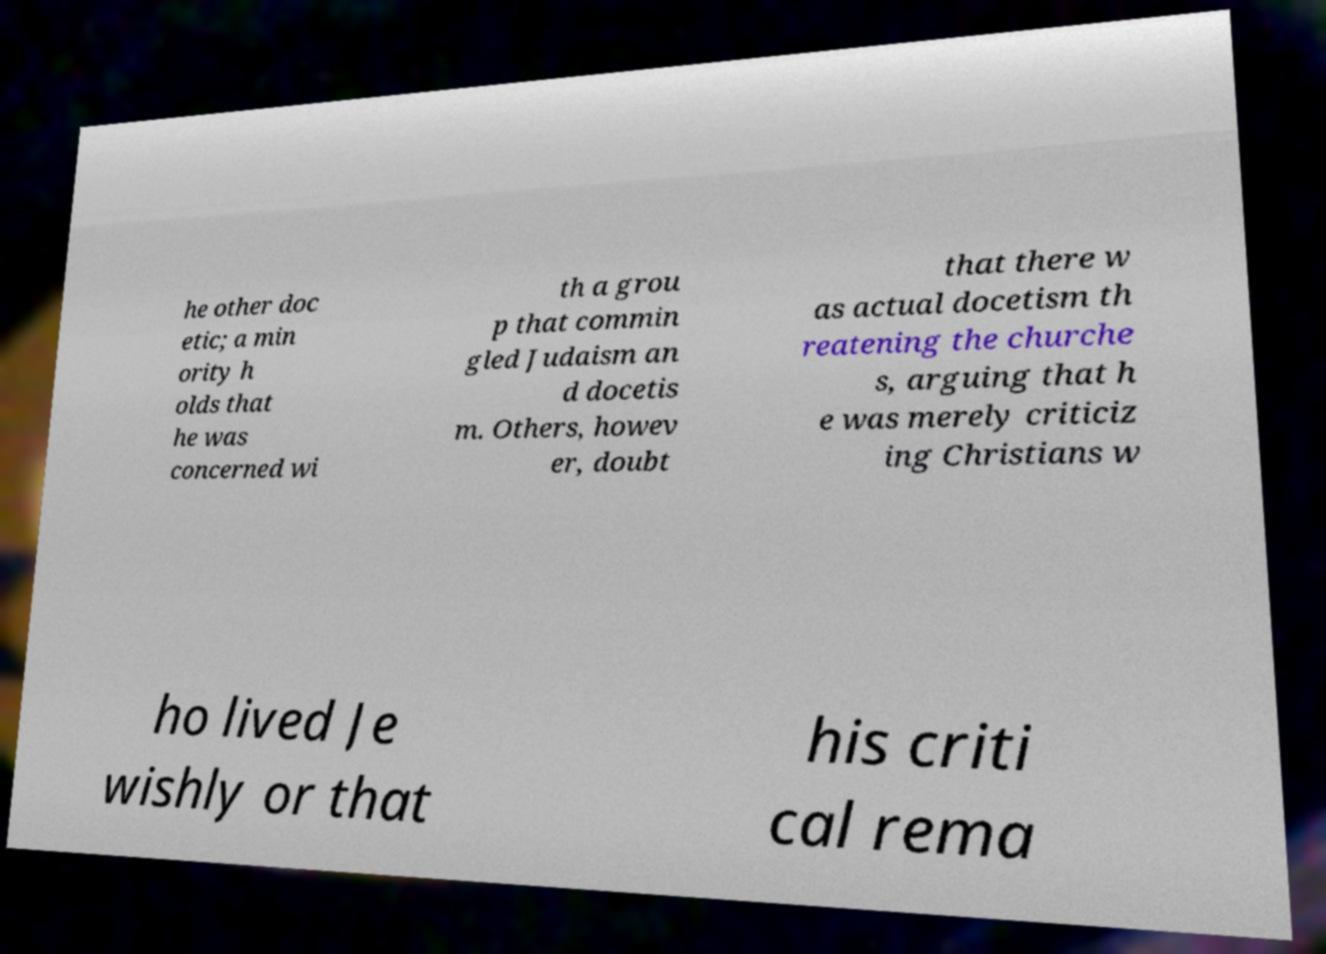What messages or text are displayed in this image? I need them in a readable, typed format. he other doc etic; a min ority h olds that he was concerned wi th a grou p that commin gled Judaism an d docetis m. Others, howev er, doubt that there w as actual docetism th reatening the churche s, arguing that h e was merely criticiz ing Christians w ho lived Je wishly or that his criti cal rema 